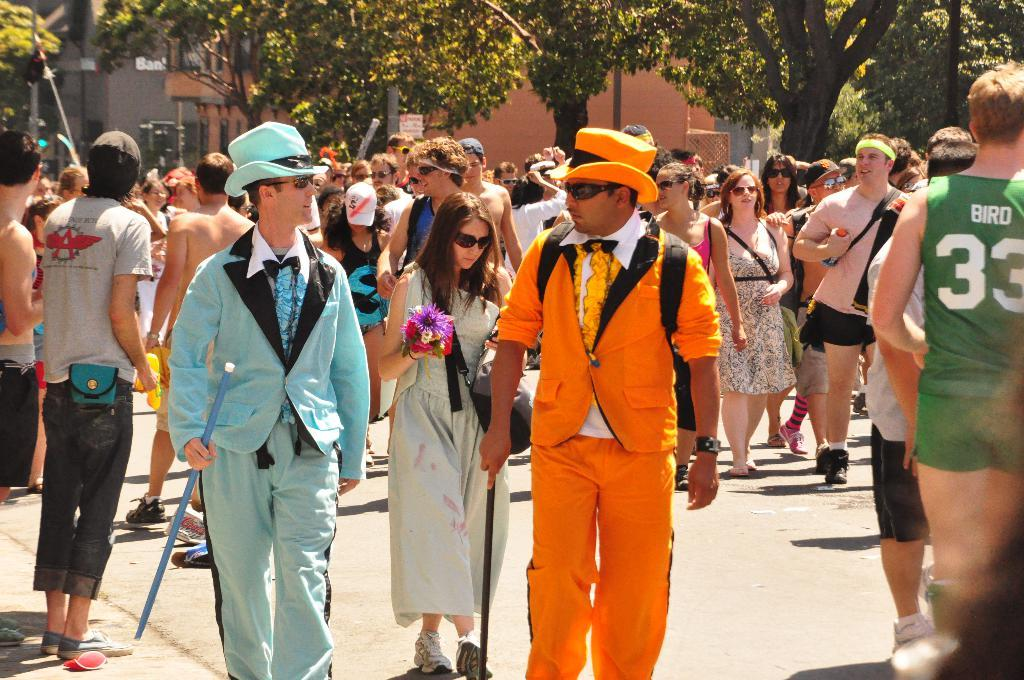What is happening in the foreground of the image? There are people on the street in the foreground of the image. What can be seen in the background of the image? There are trees, buildings, signal lights, and other objects visible in the background of the image. Can you describe the setting of the image? The image shows a street scene with people in the foreground and various structures and vegetation in the background. What type of orange is displayed on the shelf in the image? There is no orange or shelf present in the image. What kind of approval is being sought by the people in the image? There is no indication in the image that the people are seeking any kind of approval. 